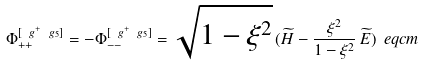Convert formula to latex. <formula><loc_0><loc_0><loc_500><loc_500>\Phi _ { + + } ^ { [ \ g ^ { + } \ g _ { 5 } ] } = - \Phi _ { - - } ^ { [ \ g ^ { + } \ g _ { 5 } ] } = { \sqrt { 1 - \xi ^ { 2 } } } \, ( \widetilde { H } - \frac { \xi ^ { 2 } } { 1 - \xi ^ { 2 } } \, \widetilde { E } ) \ e q c m</formula> 